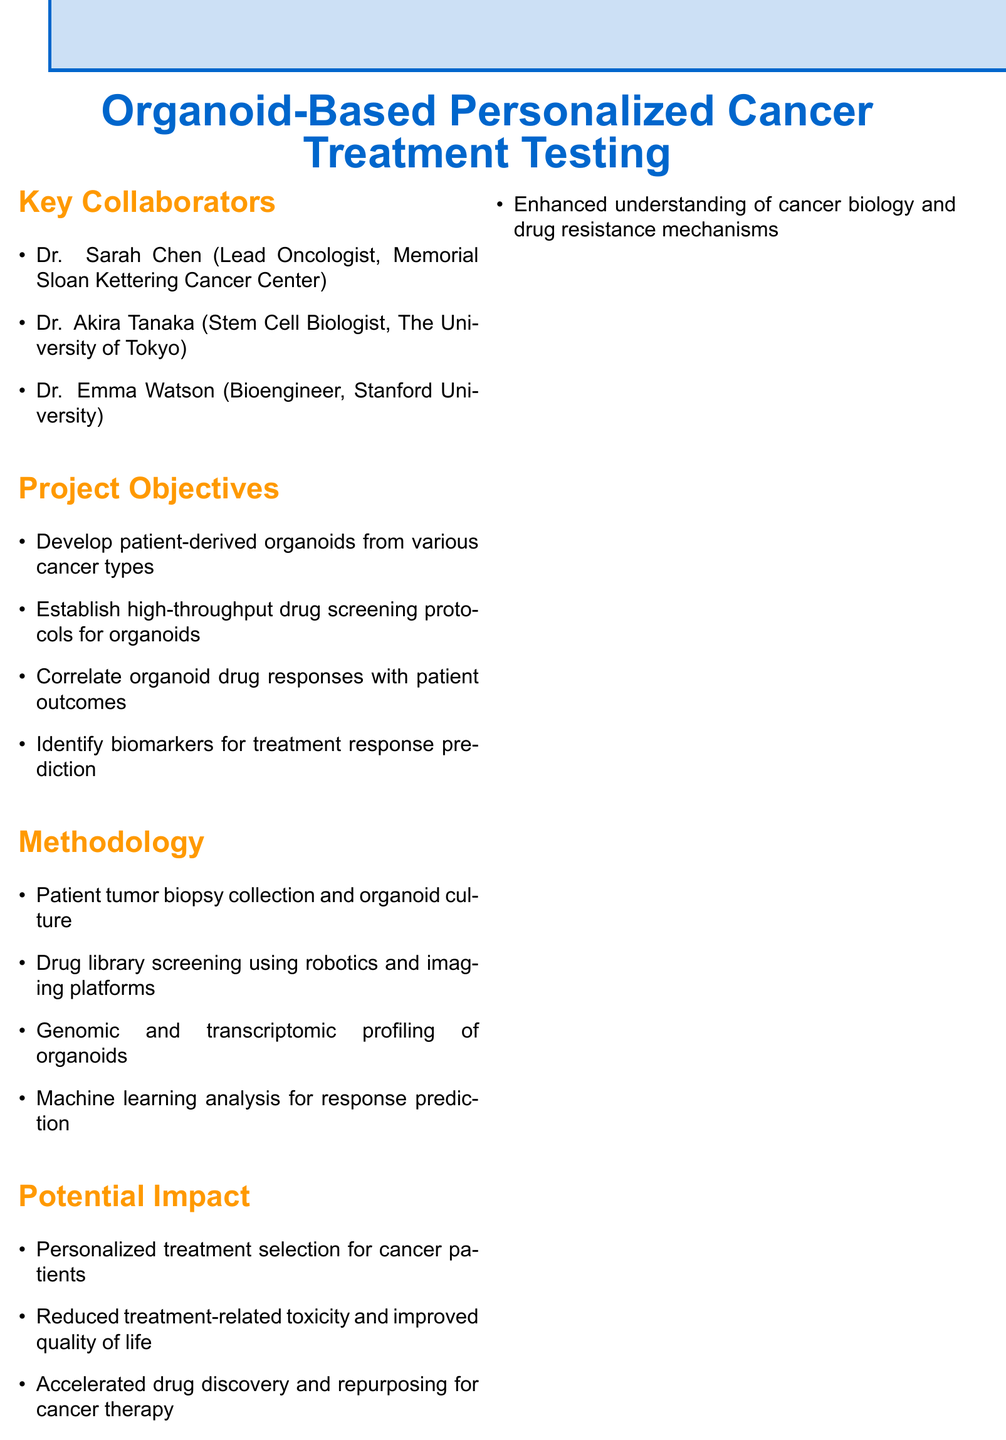What is the project title? The project title is explicitly stated at the beginning of the document.
Answer: Organoid-Based Personalized Cancer Treatment Testing Who is the Lead Oncologist in the project? The document lists the key collaborators and their roles, including the Lead Oncologist.
Answer: Dr. Sarah Chen What is the start date of the project? The start date is provided in the timeline section of the document.
Answer: 2024-01-01 How many years is the project expected to last? The duration of the project is specified in the timeline section.
Answer: 5 years Which organization is one of the funding sources? The document mentions several funding sources under a specific section.
Answer: National Cancer Institute (NCI) What is one objective of the project? The document outlines several project objectives in a list format.
Answer: Develop patient-derived organoids from various cancer types Which ethical consideration relates to data? The document includes a section on ethical considerations relevant to the project.
Answer: Data privacy What milestone is expected to be completed by Year 3? The timeline section provides specific milestones for each year of the project.
Answer: Complete drug screening and initiate clinical validation What type of analysis will be used for response prediction? The methodology section lists the types of analyses planned for the project.
Answer: Machine learning analysis What is a potential impact of using organoids in cancer treatment? The document outline potential impacts that result from the project.
Answer: Reduced treatment-related toxicity and improved quality of life 